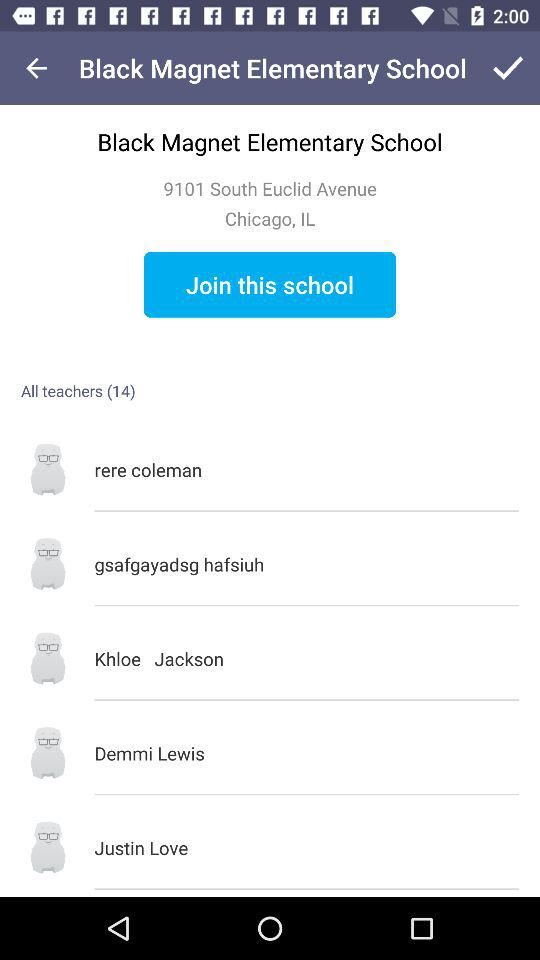What is the address of the school? The address is 9101 South Euclid Avenue, Chicago, IL. 